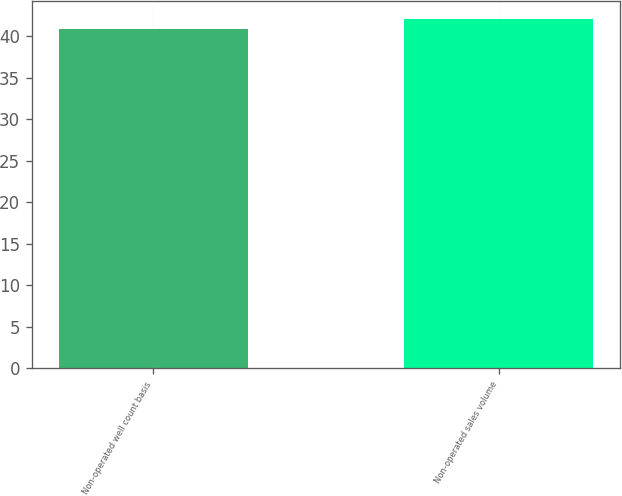Convert chart. <chart><loc_0><loc_0><loc_500><loc_500><bar_chart><fcel>Non-operated well count basis<fcel>Non-operated sales volume<nl><fcel>40.8<fcel>42.1<nl></chart> 